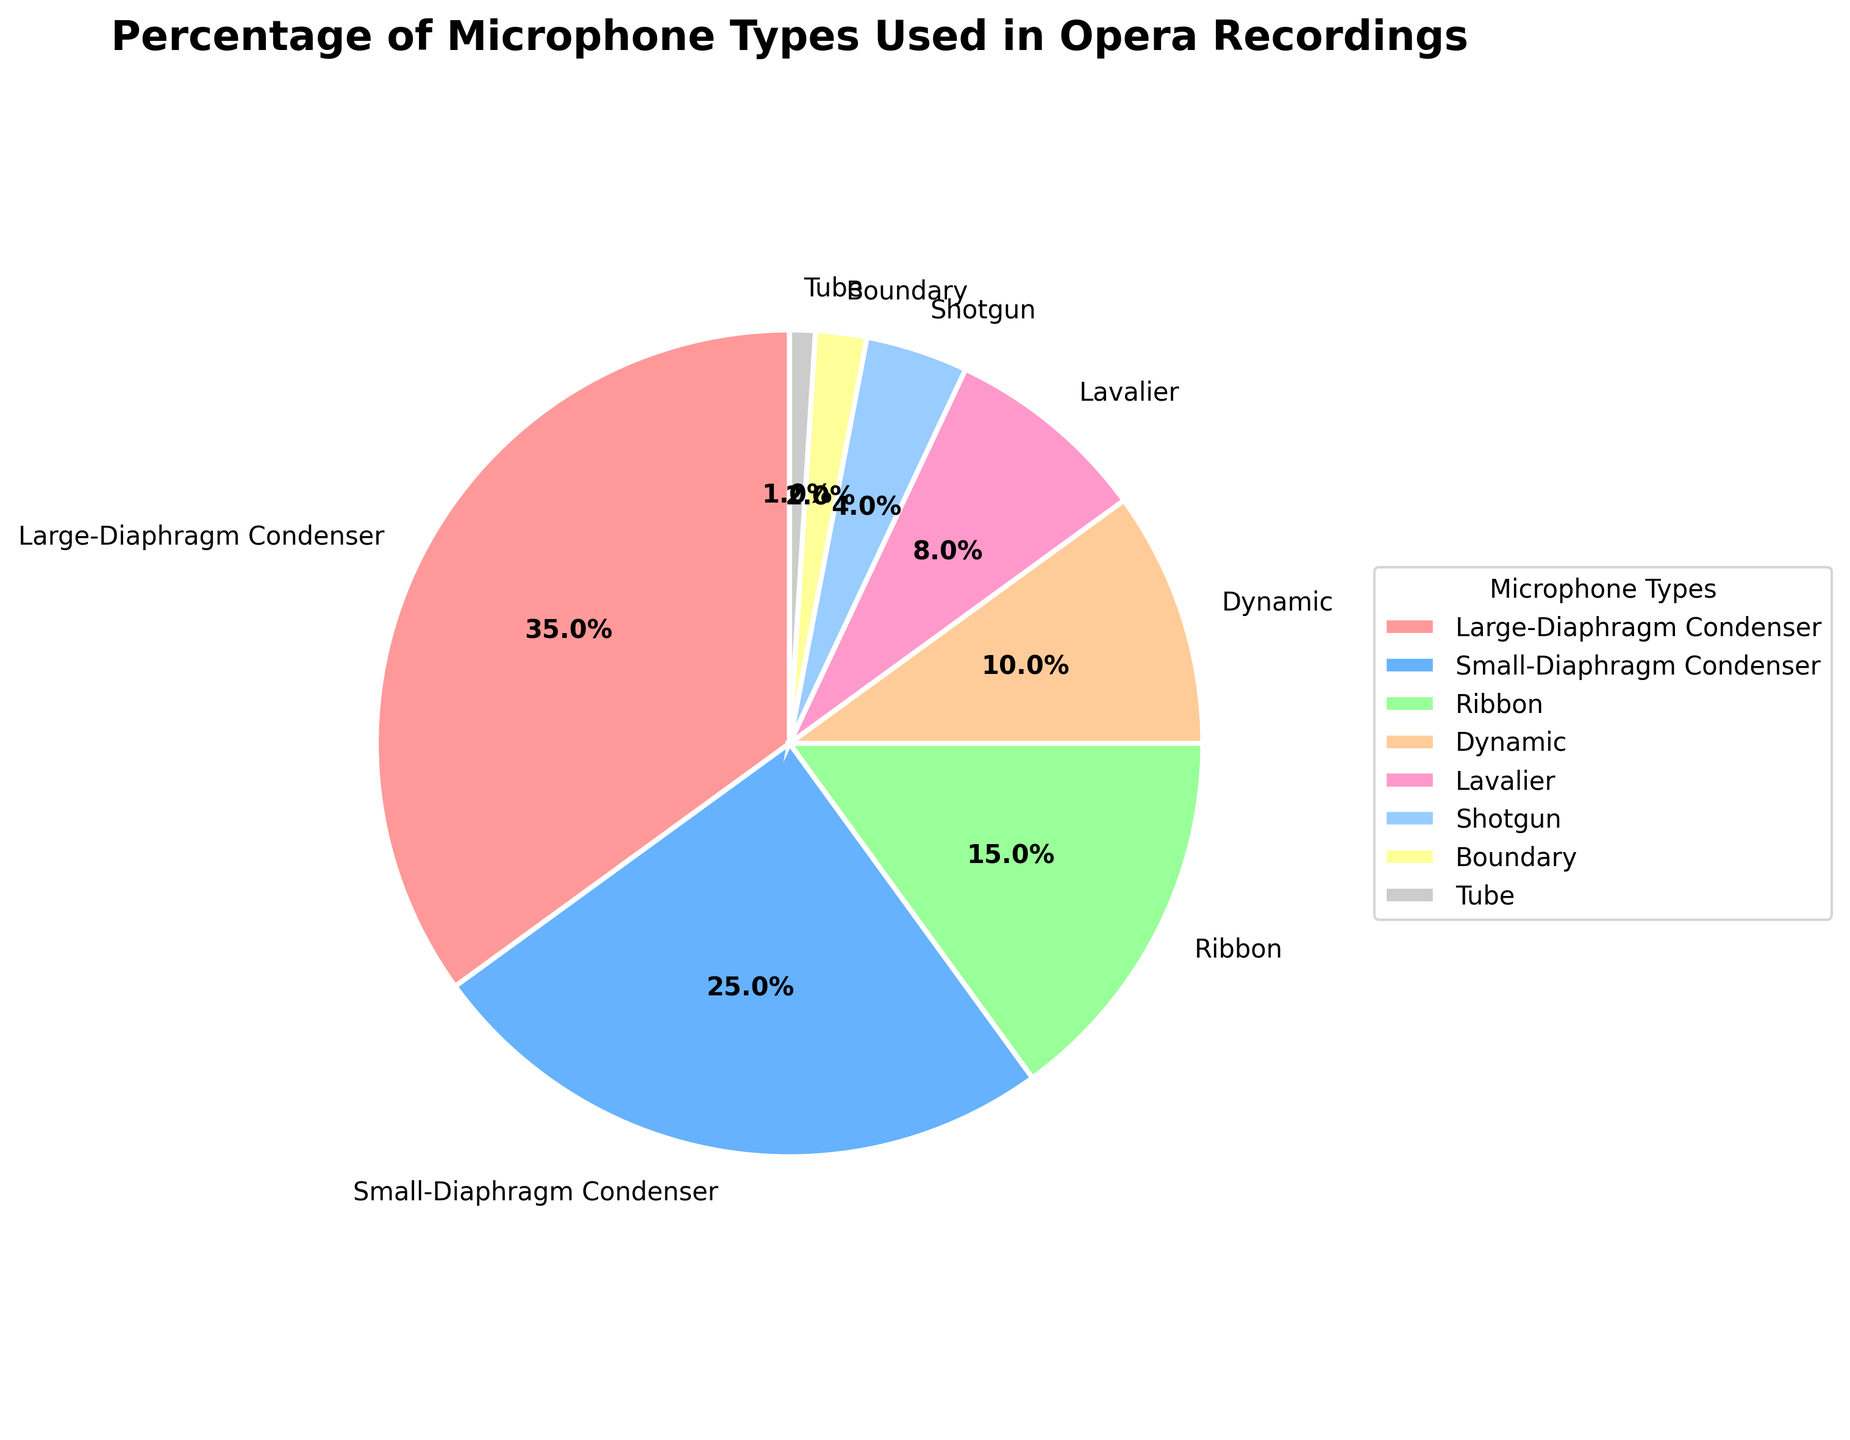Which microphone type is used the most frequently in opera recordings? By observing the sizes of the pie sections, it is clear that the 'Large-Diaphragm Condenser' has the largest section of the pie, indicating it has the highest percentage usage.
Answer: Large-Diaphragm Condenser What is the combined percentage of 'Ribbon' and 'Dynamic' microphone types? 'Ribbon' microphones account for 15%, and 'Dynamic' microphones account for 10%. Adding these together gives 15% + 10% = 25%.
Answer: 25% Is the usage percentage of 'Small-Diaphragm Condenser' microphones greater than 'Ribbon' microphones? Upon examining the sections of the pie chart, the 'Small-Diaphragm Condenser' represents 25%, which is greater than the 'Ribbon' microphones at 15%.
Answer: Yes Which microphone type has the lowest percentage usage? By looking at the smallest section of the pie chart, the 'Tube' microphone has the lowest percentage usage at 1%.
Answer: Tube Compare the usage of 'Lavalier' and 'Shotgun' microphones. Which one is used more, and by how much? 'Lavalier' microphones account for 8% usage, while 'Shotgun' microphones account for 4%. The difference in usage is 8% - 4% = 4%.
Answer: Lavalier by 4% What percentage of microphone types together account for less than 10% each? The microphones with usage percentages below 10% are 'Dynamic' (10%), 'Lavalier' (8%), 'Shotgun' (4%), 'Boundary' (2%), and 'Tube' (1%). Adding these together gives 10% + 8% + 4% + 2% + 1% = 25%.
Answer: 25% How much more frequently are 'Large-Diaphragm Condenser' microphones used compared to 'Tube' microphones? 'Large-Diaphragm Condenser' microphones account for 35%, while 'Tube' microphones are at 1%. The difference is 35% - 1% = 34%.
Answer: 34% Which two microphone types together make up more than half of the total usage? 'Large-Diaphragm Condenser' (35%) and 'Small-Diaphragm Condenser' (25%) together make up 35% + 25% = 60%, which is more than half (50%) of the total usage.
Answer: Large-Diaphragm Condenser and Small-Diaphragm Condenser 